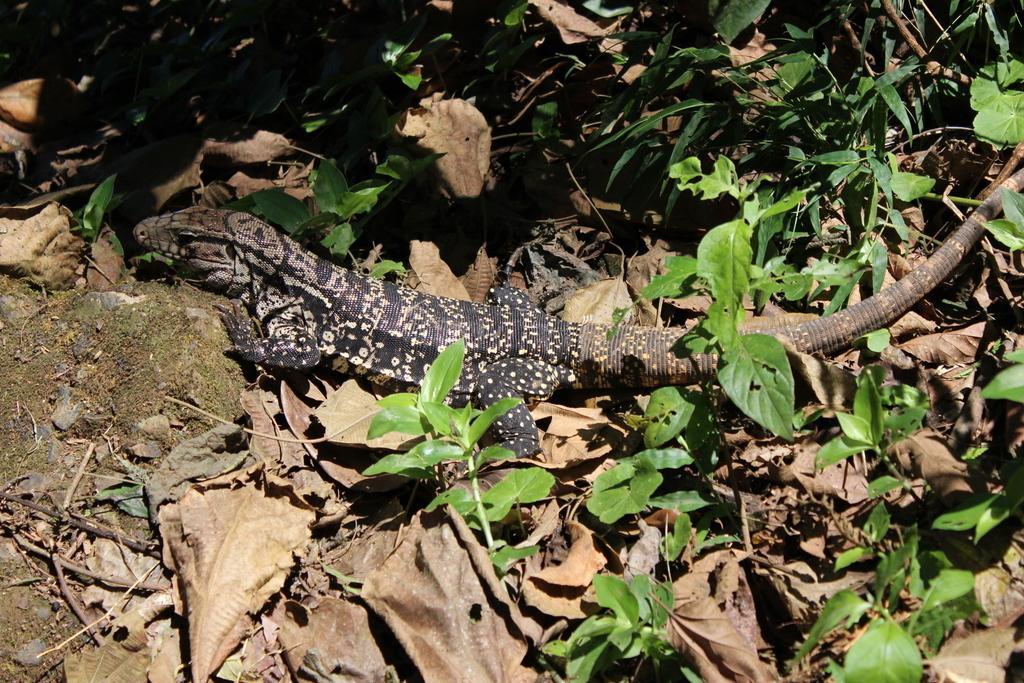Could you give a brief overview of what you see in this image? In this picture we can see a reptile, leaves and a few things. 